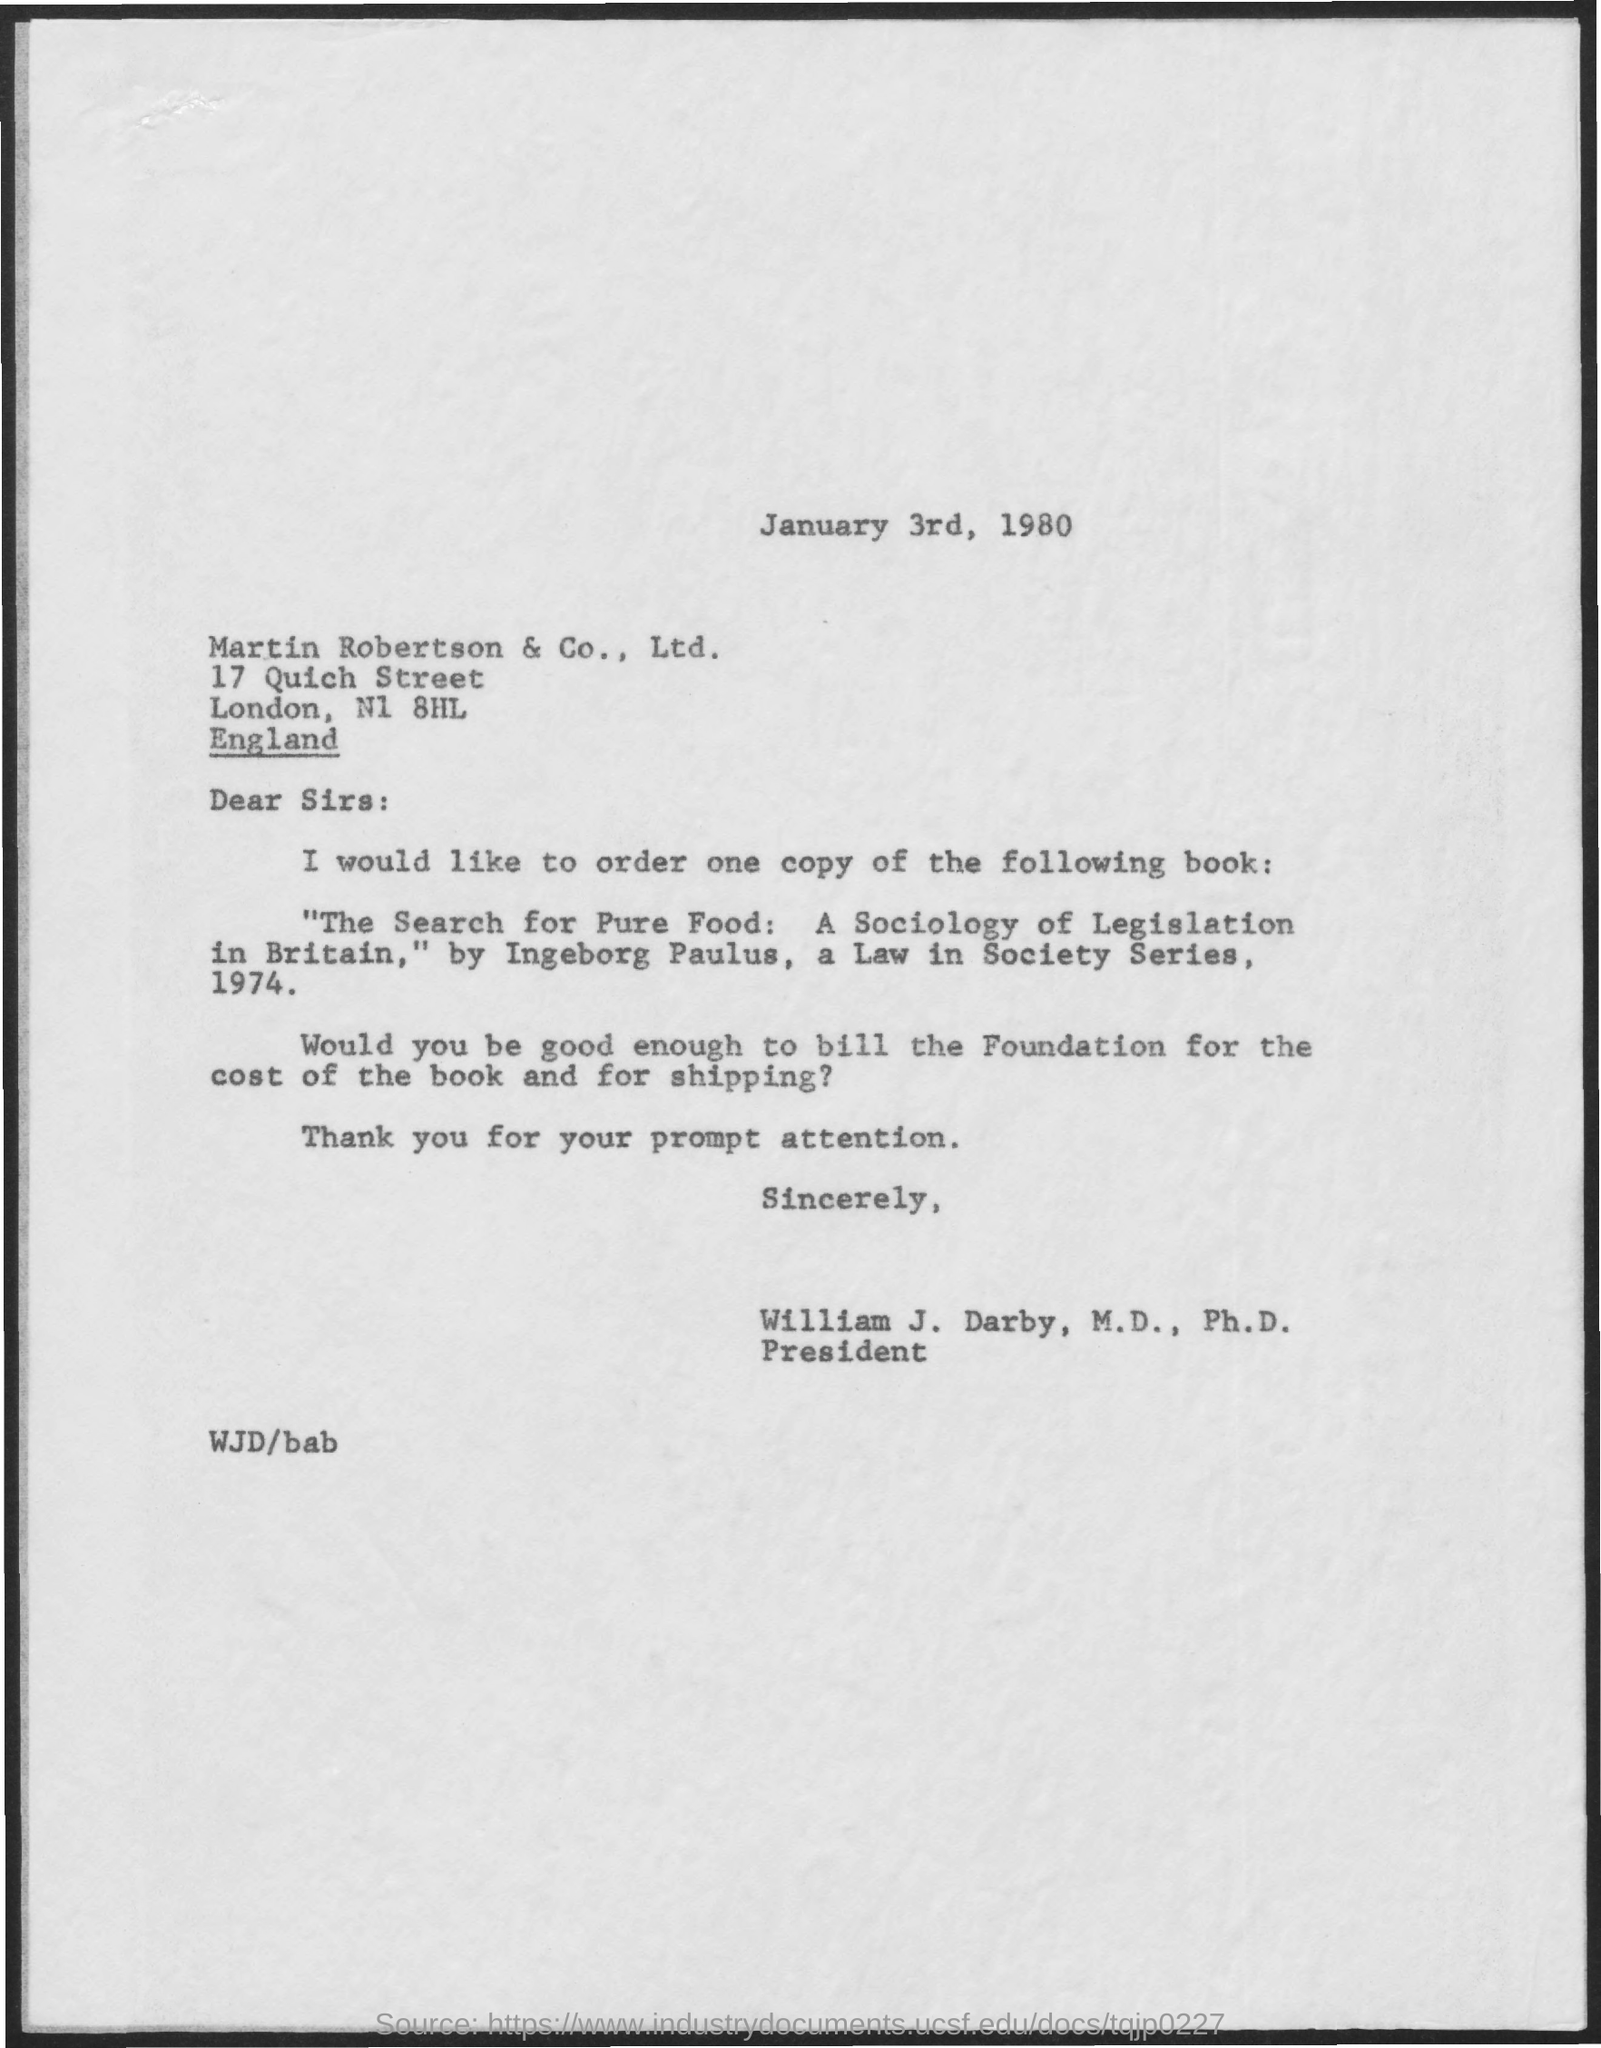Identify some key points in this picture. This letter is addressed to MARTIN ROBERTSON & CO., LTD. The date mentioned in this letter is January 3rd, 1980. 